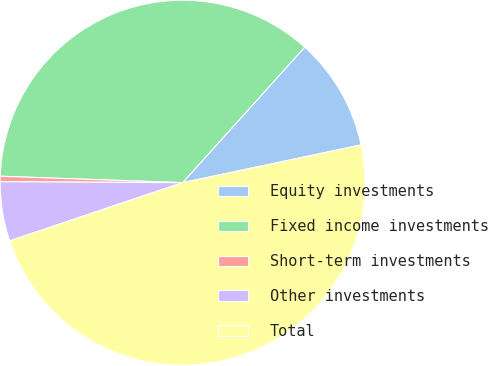Convert chart. <chart><loc_0><loc_0><loc_500><loc_500><pie_chart><fcel>Equity investments<fcel>Fixed income investments<fcel>Short-term investments<fcel>Other investments<fcel>Total<nl><fcel>10.01%<fcel>36.11%<fcel>0.48%<fcel>5.25%<fcel>48.15%<nl></chart> 